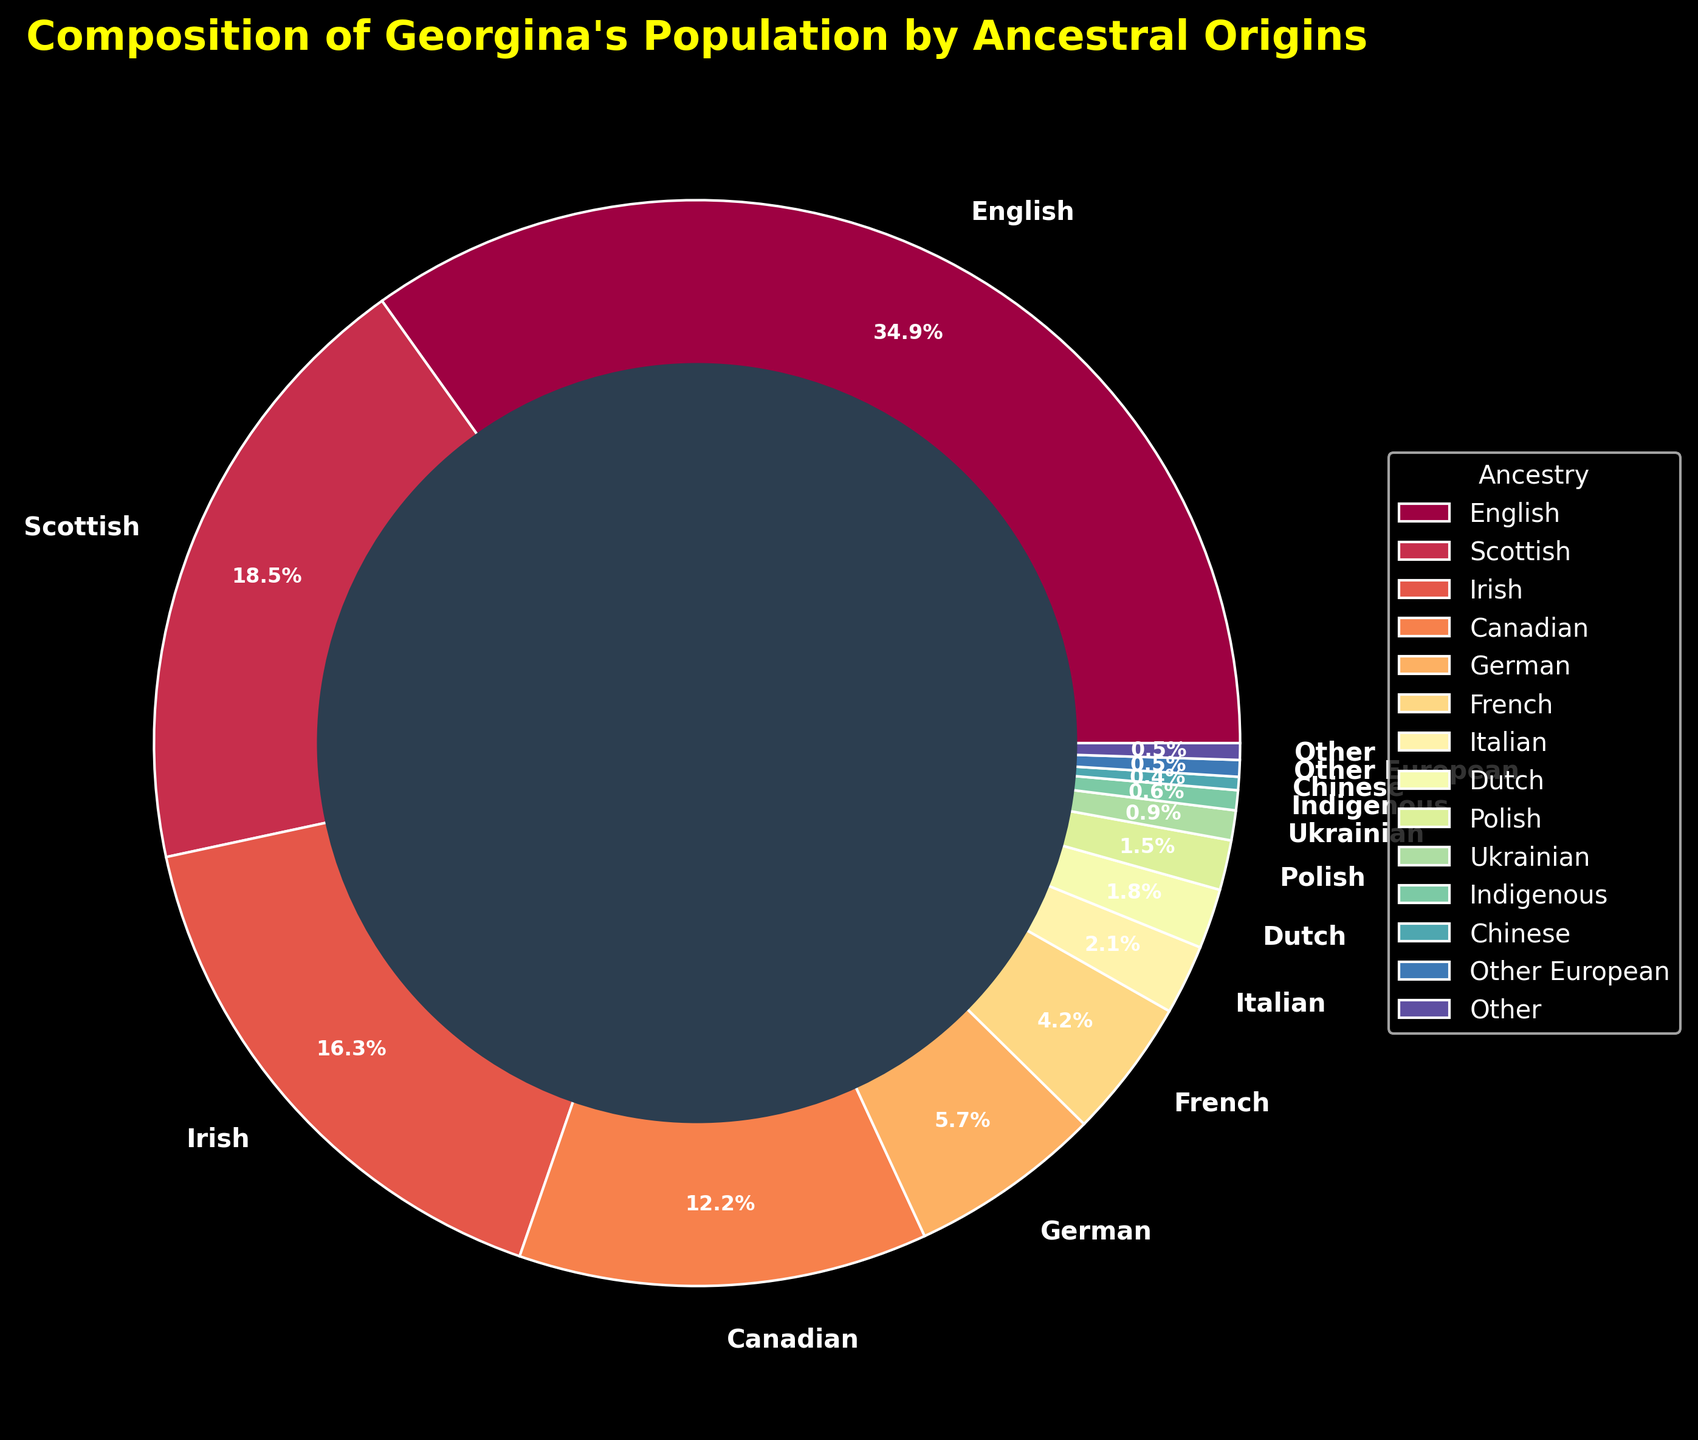What is the most common ancestry in Georgina's population? The largest portion of the pie chart is labeled "English," indicating it has the highest percentage.
Answer: English Which ancestry has a greater percentage, Irish or Scottish? From the pie chart, the Irish section is labeled 16.5%, while the Scottish section is labeled 18.7%. Scottish is greater.
Answer: Scottish What is the combined percentage of English, Scottish, and Irish ancestries? Adding the percentages from the pie chart for English (35.2%), Scottish (18.7%), and Irish (16.5%): 35.2 + 18.7 + 16.5 = 70.4%
Answer: 70.4% Is the combined percentage of Canadian and German ancestries greater than the English ancestry? Sum the percentages of Canadian (12.3%) and German (5.8%) from the pie chart and compare it to English (35.2%): 12.3 + 5.8 = 18.1%, which is less than 35.2%.
Answer: No What color represents the Italian ancestry section, and what is its percentage? The Italian ancestry section is shown in the pie chart with a color derived from the spectral colormap (likely a specific shade depending on the color order) and is labeled 2.1%.
Answer: 2.1% What is the difference in percentage between French and Indigenous ancestries? Subtract the Indigenous percentage from the French percentage based on the pie chart values: 4.2% - 0.6% = 3.6%
Answer: 3.6% Are Chinese or Indigenous ancestries included in the chart, and if so, what are their percentages? Both ancestries are included in the pie chart. The Chinese is labeled 0.4%, and Indigenous is labeled 0.6%.
Answer: Indigenous: 0.6%, Chinese: 0.4% What visual attribute distinguishes the donut chart from a standard pie chart? The donut chart has a central hole, created by adding a circle in the middle, distinguishing it from a standard pie chart.
Answer: Central hole Which ancestries have a percentage less than 1%? From the pie chart, Indigenous (0.6%), Chinese (0.4%), Other European (0.5%), and Other (0.5%) are all less than 1%.
Answer: Indigenous, Chinese, Other European, Other What is the total percentage of ancestries classified as "Other" and "Other European"? Adding the percentages from the pie chart for "Other" (0.5%) and "Other European" (0.5%): 0.5 + 0.5 = 1.0%
Answer: 1.0% 